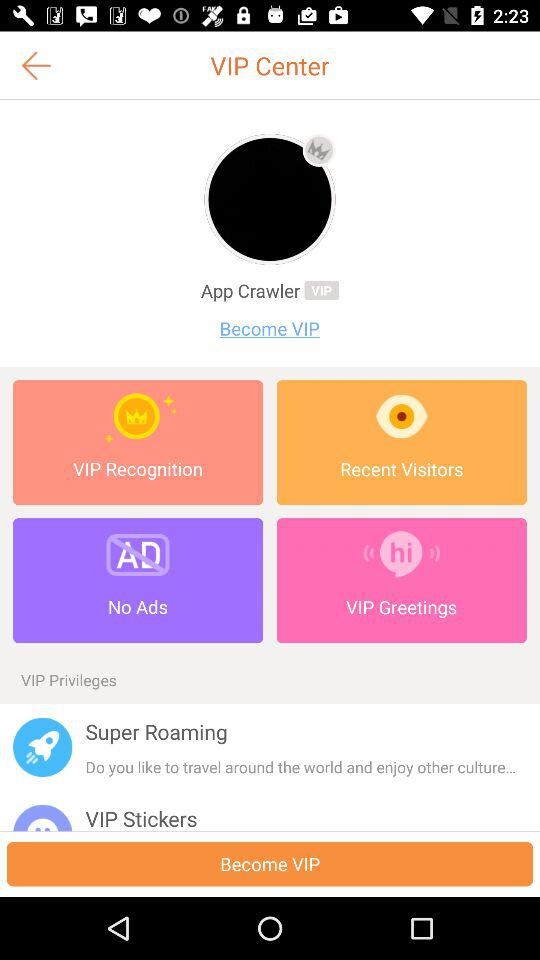What is the user name? The user name is App Crawler. 